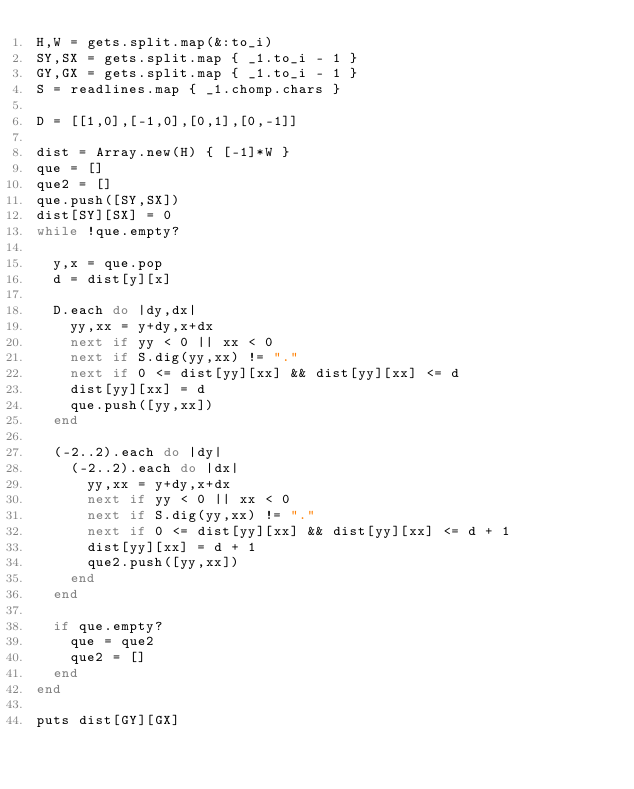<code> <loc_0><loc_0><loc_500><loc_500><_Ruby_>H,W = gets.split.map(&:to_i)
SY,SX = gets.split.map { _1.to_i - 1 }
GY,GX = gets.split.map { _1.to_i - 1 }
S = readlines.map { _1.chomp.chars }

D = [[1,0],[-1,0],[0,1],[0,-1]]

dist = Array.new(H) { [-1]*W }
que = []
que2 = []
que.push([SY,SX])
dist[SY][SX] = 0
while !que.empty?
  
  y,x = que.pop
  d = dist[y][x]

  D.each do |dy,dx|
    yy,xx = y+dy,x+dx
    next if yy < 0 || xx < 0
    next if S.dig(yy,xx) != "."
    next if 0 <= dist[yy][xx] && dist[yy][xx] <= d
    dist[yy][xx] = d
    que.push([yy,xx])
  end
  
  (-2..2).each do |dy|
    (-2..2).each do |dx|
      yy,xx = y+dy,x+dx
      next if yy < 0 || xx < 0
      next if S.dig(yy,xx) != "."
      next if 0 <= dist[yy][xx] && dist[yy][xx] <= d + 1
      dist[yy][xx] = d + 1
      que2.push([yy,xx])
    end
  end
  
  if que.empty?
    que = que2
    que2 = []
  end
end

puts dist[GY][GX]
</code> 